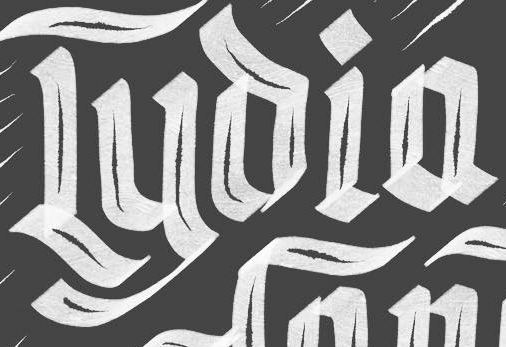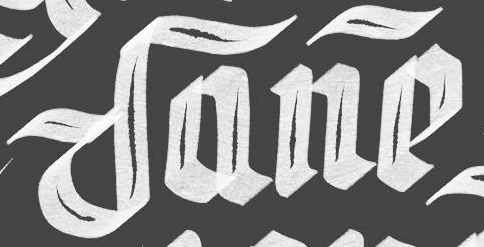What words are shown in these images in order, separated by a semicolon? Lyoia; Dane 